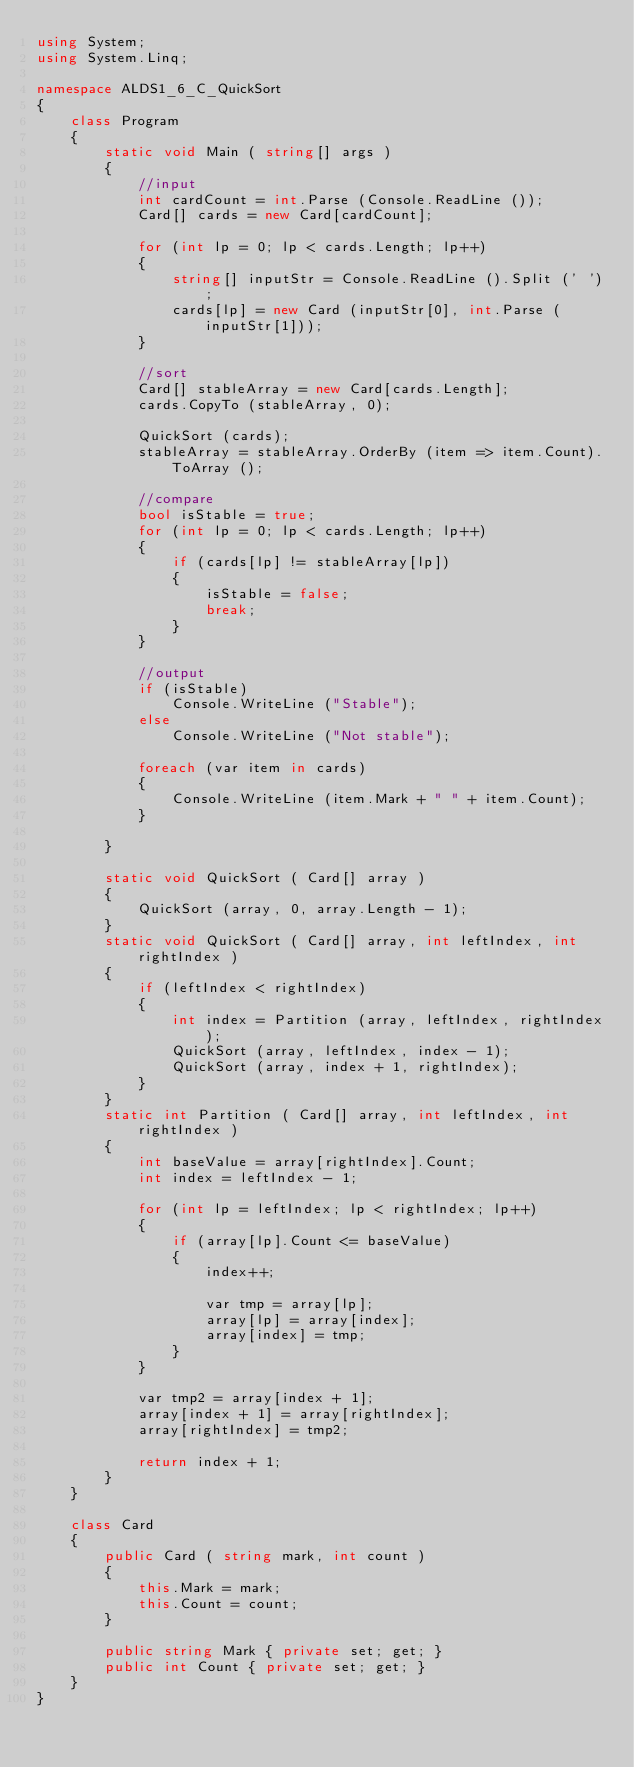Convert code to text. <code><loc_0><loc_0><loc_500><loc_500><_C#_>using System;
using System.Linq;

namespace ALDS1_6_C_QuickSort
{
	class Program
	{
		static void Main ( string[] args )
		{
			//input
			int cardCount = int.Parse (Console.ReadLine ());
			Card[] cards = new Card[cardCount];

			for (int lp = 0; lp < cards.Length; lp++)
			{
				string[] inputStr = Console.ReadLine ().Split (' ');
				cards[lp] = new Card (inputStr[0], int.Parse (inputStr[1]));
			}

			//sort
			Card[] stableArray = new Card[cards.Length];
			cards.CopyTo (stableArray, 0);

			QuickSort (cards);
			stableArray = stableArray.OrderBy (item => item.Count).ToArray ();

			//compare
			bool isStable = true;
			for (int lp = 0; lp < cards.Length; lp++)
			{
				if (cards[lp] != stableArray[lp])
				{
					isStable = false;
					break;
				}
			}

			//output
			if (isStable)
				Console.WriteLine ("Stable");
			else
				Console.WriteLine ("Not stable");

			foreach (var item in cards)
			{
				Console.WriteLine (item.Mark + " " + item.Count);
			}

		}

		static void QuickSort ( Card[] array )
		{
			QuickSort (array, 0, array.Length - 1);
		}
		static void QuickSort ( Card[] array, int leftIndex, int rightIndex )
		{
			if (leftIndex < rightIndex)
			{
				int index = Partition (array, leftIndex, rightIndex);
				QuickSort (array, leftIndex, index - 1);
				QuickSort (array, index + 1, rightIndex);
			}
		}
		static int Partition ( Card[] array, int leftIndex, int rightIndex )
		{
			int baseValue = array[rightIndex].Count;
			int index = leftIndex - 1;

			for (int lp = leftIndex; lp < rightIndex; lp++)
			{
				if (array[lp].Count <= baseValue)
				{
					index++;

					var tmp = array[lp];
					array[lp] = array[index];
					array[index] = tmp;
				}
			}

			var tmp2 = array[index + 1];
			array[index + 1] = array[rightIndex];
			array[rightIndex] = tmp2;

			return index + 1;
		}
	}

	class Card
	{
		public Card ( string mark, int count )
		{
			this.Mark = mark;
			this.Count = count;
		}

		public string Mark { private set; get; }
		public int Count { private set; get; }
	}
}</code> 